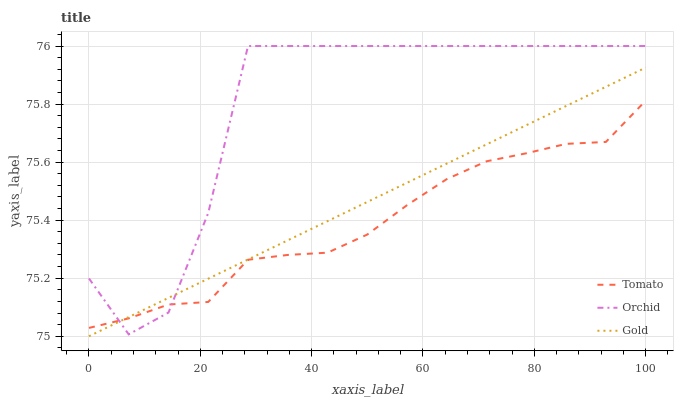Does Tomato have the minimum area under the curve?
Answer yes or no. Yes. Does Orchid have the maximum area under the curve?
Answer yes or no. Yes. Does Gold have the minimum area under the curve?
Answer yes or no. No. Does Gold have the maximum area under the curve?
Answer yes or no. No. Is Gold the smoothest?
Answer yes or no. Yes. Is Orchid the roughest?
Answer yes or no. Yes. Is Orchid the smoothest?
Answer yes or no. No. Is Gold the roughest?
Answer yes or no. No. Does Gold have the lowest value?
Answer yes or no. Yes. Does Orchid have the lowest value?
Answer yes or no. No. Does Orchid have the highest value?
Answer yes or no. Yes. Does Gold have the highest value?
Answer yes or no. No. Does Orchid intersect Gold?
Answer yes or no. Yes. Is Orchid less than Gold?
Answer yes or no. No. Is Orchid greater than Gold?
Answer yes or no. No. 